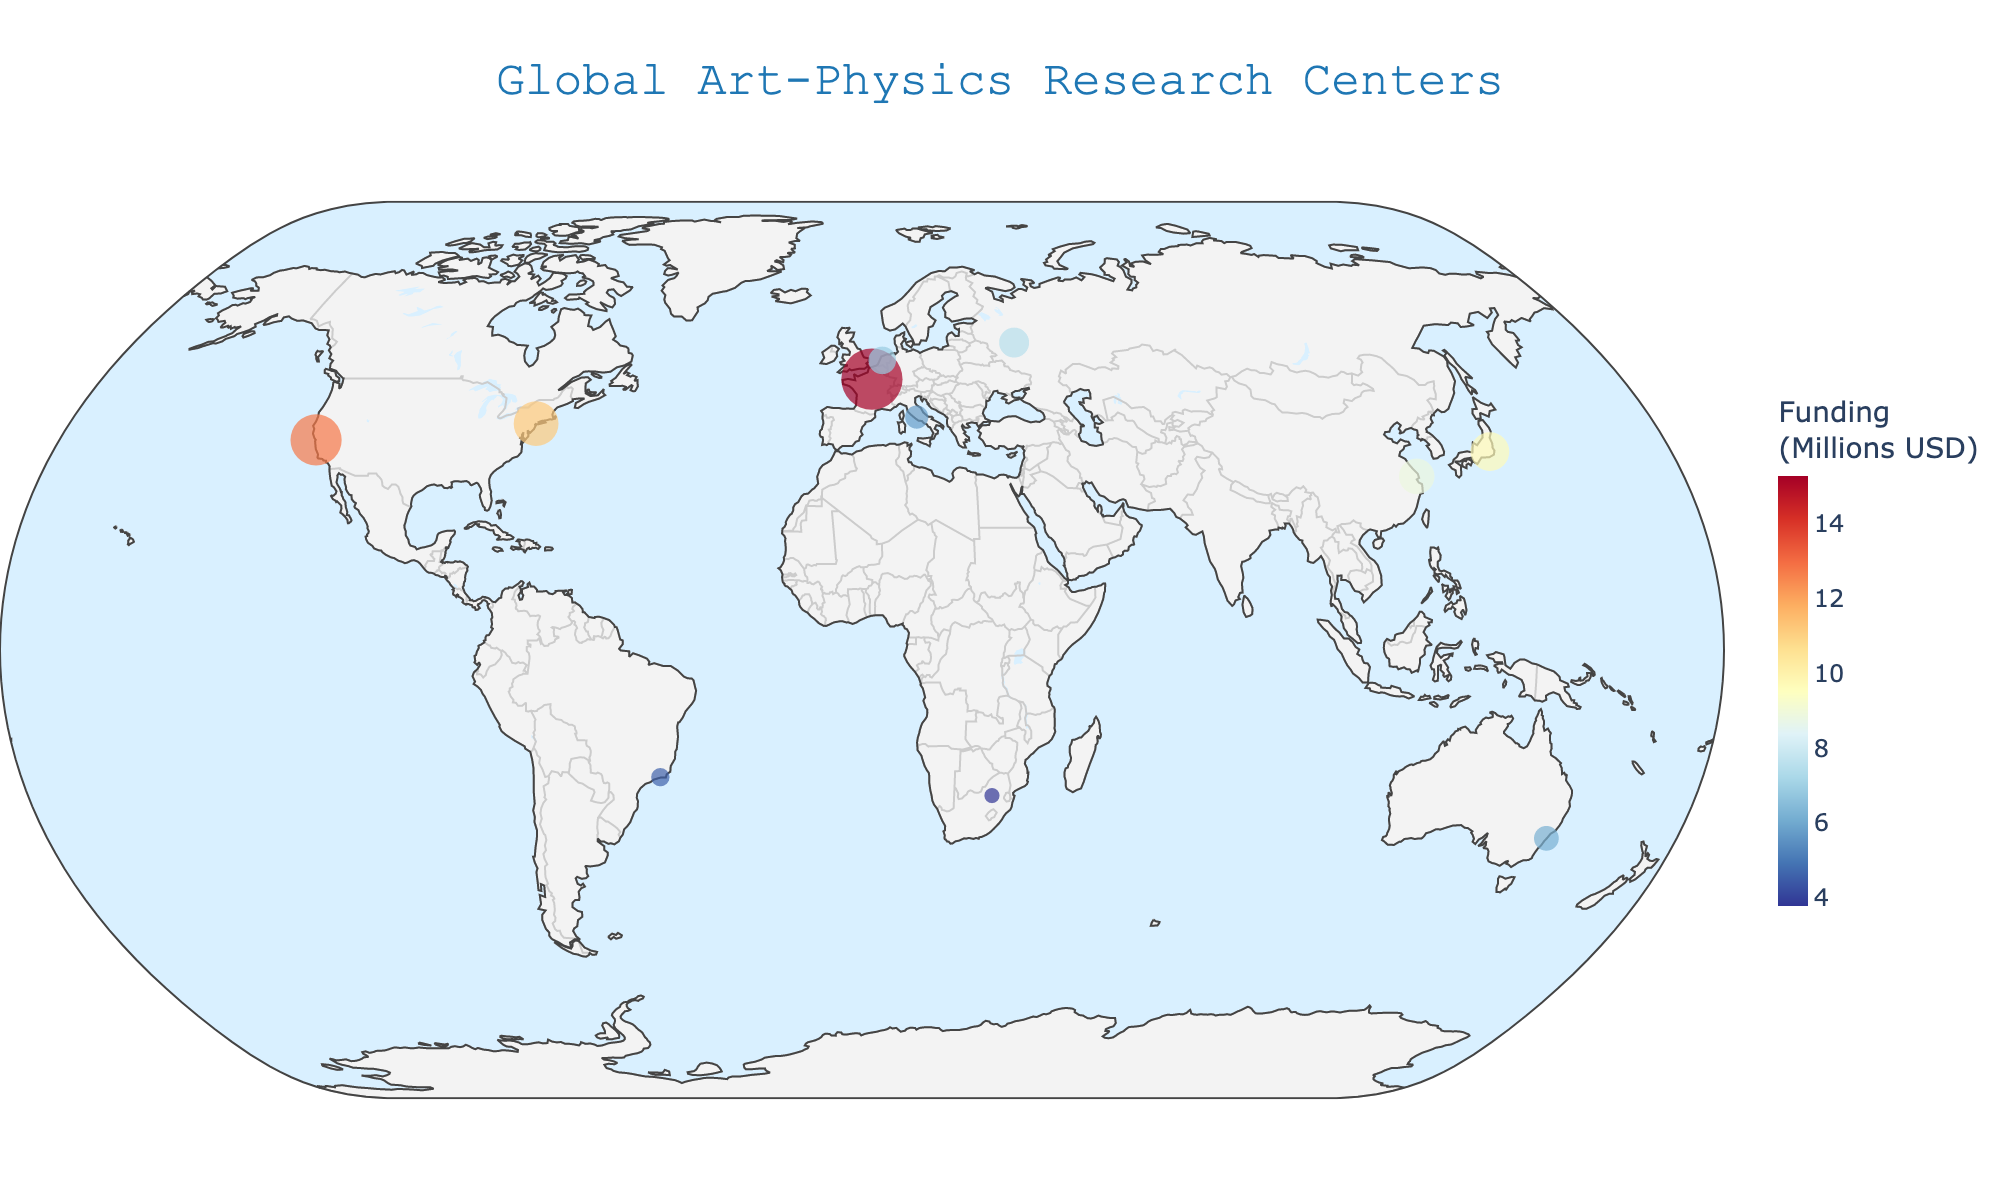What is the title of the figure? The title is typically located at the top of the figure, centered, and contains the main subject of the visualization. Here, the title reads "Global Art-Physics Research Centers".
Answer: Global Art-Physics Research Centers How many total data points are represented on the map? By counting the markers visible on the map, you can determine the total number of data points. Here, there are markers in Paris, Stanford, Tokyo, Moscow, Sydney, Shanghai, Rome, Rio, Amsterdam, New York, and Johannesburg.
Answer: 11 Which region has the highest funding allocated? By observing the color and size of the markers, and referring to the color scale indicating funding, we can identify that Europe, especially marked by CERN in Paris with $15.3 million, has the highest funding.
Answer: Europe How many research centers are located in Asia? By identifying the geographic locations on the map that belong to Asia (Tokyo and Shanghai), we count the centers in that region.
Answer: 2 What is the total funding allocated to European research centers? There are four centers in Europe (Paris, Moscow, Rome, Amsterdam). Summing their funding: 15.3 + 7.5 + 5.8 + 6.9
Answer: The total is $35.5 million What is the average funding of research centers in North America? North America has two centers (Stanford and New York). Adding their funding: 12.8 + 11.2 = 24. Dividing by 2 gives the average funding.
Answer: $12 million Which research center has the smallest funding? The smallest marker size and its corresponding funding value on the color scale indicate the lowest funding. Johannesburg Astroparticle Art Center has the smallest funding at $3.8 million.
Answer: Johannesburg Astroparticle Art Center Which research center is located farthest south? By checking the geographic coordinates (latitude), Sydney in Oceania at latitude -33.8688 is the farthest south.
Answer: Sydney Particle Visualization Project Compare the funding between European and Asian research centers. Which region has more total funding? Summing the funding in Europe ($35.5 million) and Asia ($18.6 million). Europe has a higher total funding allocation compared to Asia.
Answer: Europe has more total funding Are there any research centers in Africa, and if so, what is their funding? Identifying markers located in Africa and referring to their funding values. Johannesburg Astroparticle Art Center is the center in Africa with $3.8 million funding.
Answer: Yes, $3.8 million 